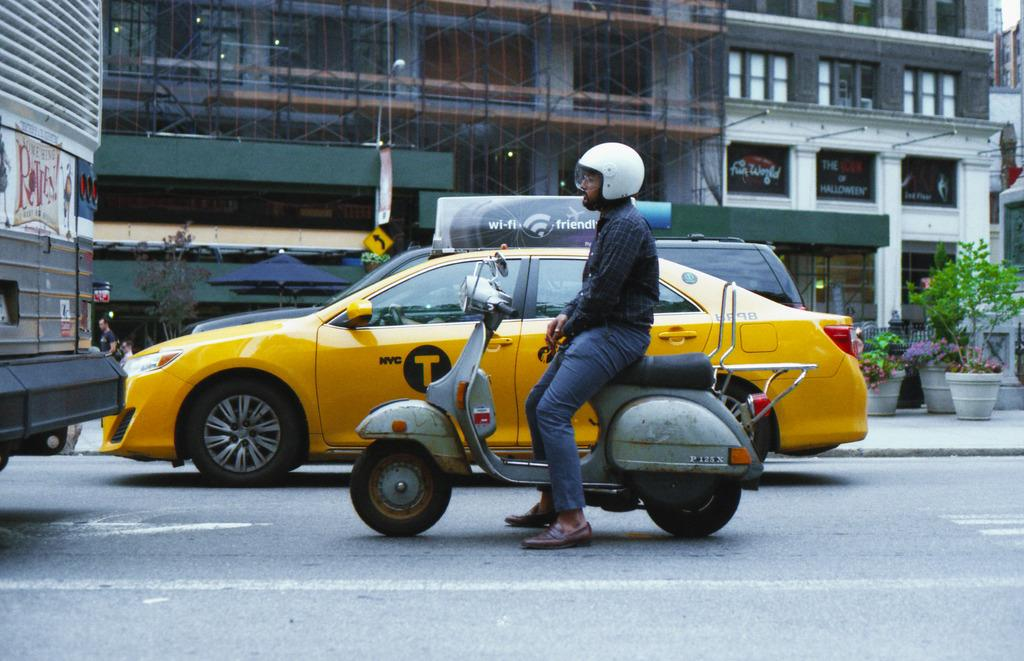Provide a one-sentence caption for the provided image. A yellow taxi with a T on its door idles in traffic next to a motorcycle. 